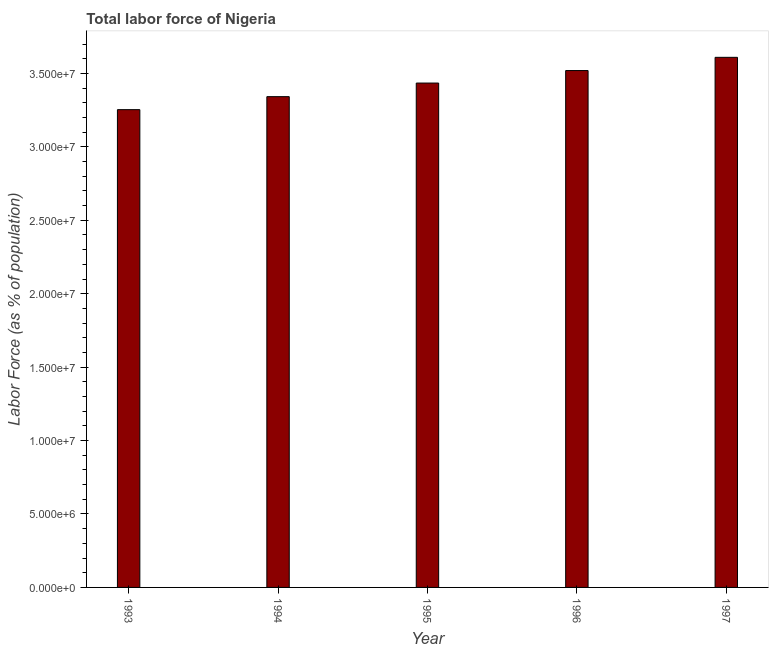Does the graph contain grids?
Your response must be concise. No. What is the title of the graph?
Your answer should be very brief. Total labor force of Nigeria. What is the label or title of the Y-axis?
Your answer should be very brief. Labor Force (as % of population). What is the total labor force in 1994?
Provide a short and direct response. 3.34e+07. Across all years, what is the maximum total labor force?
Make the answer very short. 3.61e+07. Across all years, what is the minimum total labor force?
Provide a succinct answer. 3.25e+07. In which year was the total labor force maximum?
Your answer should be compact. 1997. What is the sum of the total labor force?
Keep it short and to the point. 1.72e+08. What is the difference between the total labor force in 1994 and 1996?
Offer a very short reply. -1.78e+06. What is the average total labor force per year?
Provide a short and direct response. 3.43e+07. What is the median total labor force?
Your answer should be very brief. 3.43e+07. Do a majority of the years between 1993 and 1997 (inclusive) have total labor force greater than 6000000 %?
Your answer should be compact. Yes. What is the ratio of the total labor force in 1993 to that in 1995?
Provide a succinct answer. 0.95. Is the total labor force in 1993 less than that in 1994?
Provide a short and direct response. Yes. What is the difference between the highest and the second highest total labor force?
Ensure brevity in your answer.  9.01e+05. Is the sum of the total labor force in 1995 and 1996 greater than the maximum total labor force across all years?
Provide a short and direct response. Yes. What is the difference between the highest and the lowest total labor force?
Offer a very short reply. 3.56e+06. In how many years, is the total labor force greater than the average total labor force taken over all years?
Offer a very short reply. 3. How many bars are there?
Make the answer very short. 5. How many years are there in the graph?
Make the answer very short. 5. What is the difference between two consecutive major ticks on the Y-axis?
Provide a succinct answer. 5.00e+06. Are the values on the major ticks of Y-axis written in scientific E-notation?
Offer a very short reply. Yes. What is the Labor Force (as % of population) in 1993?
Your answer should be compact. 3.25e+07. What is the Labor Force (as % of population) of 1994?
Offer a terse response. 3.34e+07. What is the Labor Force (as % of population) of 1995?
Your answer should be compact. 3.43e+07. What is the Labor Force (as % of population) of 1996?
Ensure brevity in your answer.  3.52e+07. What is the Labor Force (as % of population) of 1997?
Ensure brevity in your answer.  3.61e+07. What is the difference between the Labor Force (as % of population) in 1993 and 1994?
Offer a terse response. -8.85e+05. What is the difference between the Labor Force (as % of population) in 1993 and 1995?
Your response must be concise. -1.81e+06. What is the difference between the Labor Force (as % of population) in 1993 and 1996?
Make the answer very short. -2.66e+06. What is the difference between the Labor Force (as % of population) in 1993 and 1997?
Make the answer very short. -3.56e+06. What is the difference between the Labor Force (as % of population) in 1994 and 1995?
Offer a very short reply. -9.26e+05. What is the difference between the Labor Force (as % of population) in 1994 and 1996?
Your answer should be compact. -1.78e+06. What is the difference between the Labor Force (as % of population) in 1994 and 1997?
Your answer should be compact. -2.68e+06. What is the difference between the Labor Force (as % of population) in 1995 and 1996?
Offer a terse response. -8.51e+05. What is the difference between the Labor Force (as % of population) in 1995 and 1997?
Provide a short and direct response. -1.75e+06. What is the difference between the Labor Force (as % of population) in 1996 and 1997?
Your response must be concise. -9.01e+05. What is the ratio of the Labor Force (as % of population) in 1993 to that in 1994?
Provide a succinct answer. 0.97. What is the ratio of the Labor Force (as % of population) in 1993 to that in 1995?
Ensure brevity in your answer.  0.95. What is the ratio of the Labor Force (as % of population) in 1993 to that in 1996?
Your answer should be compact. 0.92. What is the ratio of the Labor Force (as % of population) in 1993 to that in 1997?
Your response must be concise. 0.9. What is the ratio of the Labor Force (as % of population) in 1994 to that in 1996?
Offer a terse response. 0.95. What is the ratio of the Labor Force (as % of population) in 1994 to that in 1997?
Your answer should be compact. 0.93. What is the ratio of the Labor Force (as % of population) in 1995 to that in 1996?
Provide a succinct answer. 0.98. What is the ratio of the Labor Force (as % of population) in 1995 to that in 1997?
Ensure brevity in your answer.  0.95. 